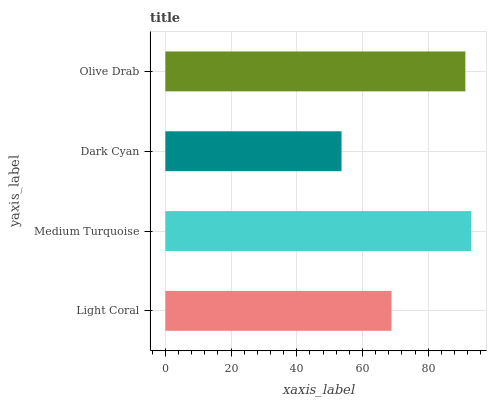Is Dark Cyan the minimum?
Answer yes or no. Yes. Is Medium Turquoise the maximum?
Answer yes or no. Yes. Is Medium Turquoise the minimum?
Answer yes or no. No. Is Dark Cyan the maximum?
Answer yes or no. No. Is Medium Turquoise greater than Dark Cyan?
Answer yes or no. Yes. Is Dark Cyan less than Medium Turquoise?
Answer yes or no. Yes. Is Dark Cyan greater than Medium Turquoise?
Answer yes or no. No. Is Medium Turquoise less than Dark Cyan?
Answer yes or no. No. Is Olive Drab the high median?
Answer yes or no. Yes. Is Light Coral the low median?
Answer yes or no. Yes. Is Medium Turquoise the high median?
Answer yes or no. No. Is Dark Cyan the low median?
Answer yes or no. No. 